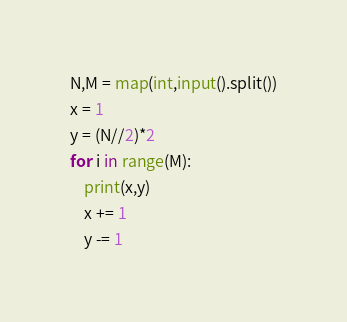<code> <loc_0><loc_0><loc_500><loc_500><_Python_>N,M = map(int,input().split())
x = 1
y = (N//2)*2
for i in range(M):
    print(x,y)
    x += 1
    y -= 1
</code> 